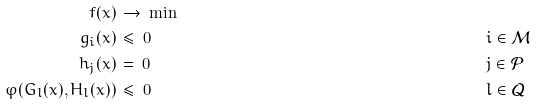Convert formula to latex. <formula><loc_0><loc_0><loc_500><loc_500>f ( x ) & \, \rightarrow \, \min & & & \\ g _ { i } ( x ) & \, \leq \, 0 & \quad & i \in \mathcal { M } & \\ h _ { j } ( x ) & \, = \, 0 & \quad & j \in \mathcal { P } & \\ \varphi ( G _ { l } ( x ) , H _ { l } ( x ) ) & \, \leq \, 0 & \quad & l \in \mathcal { Q } &</formula> 